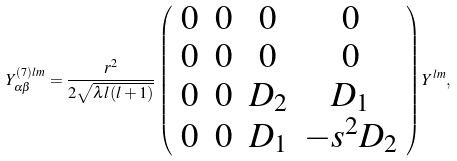Convert formula to latex. <formula><loc_0><loc_0><loc_500><loc_500>Y ^ { ( 7 ) l m } _ { \alpha \beta } = \frac { r ^ { 2 } } { 2 \sqrt { \lambda l ( l + 1 ) } } \left ( \begin{array} { c c c c } 0 & 0 & 0 & 0 \\ 0 & 0 & 0 & 0 \\ 0 & 0 & D _ { 2 } & D _ { 1 } \\ 0 & 0 & D _ { 1 } & - s ^ { 2 } D _ { 2 } \end{array} \right ) Y ^ { l m } ,</formula> 